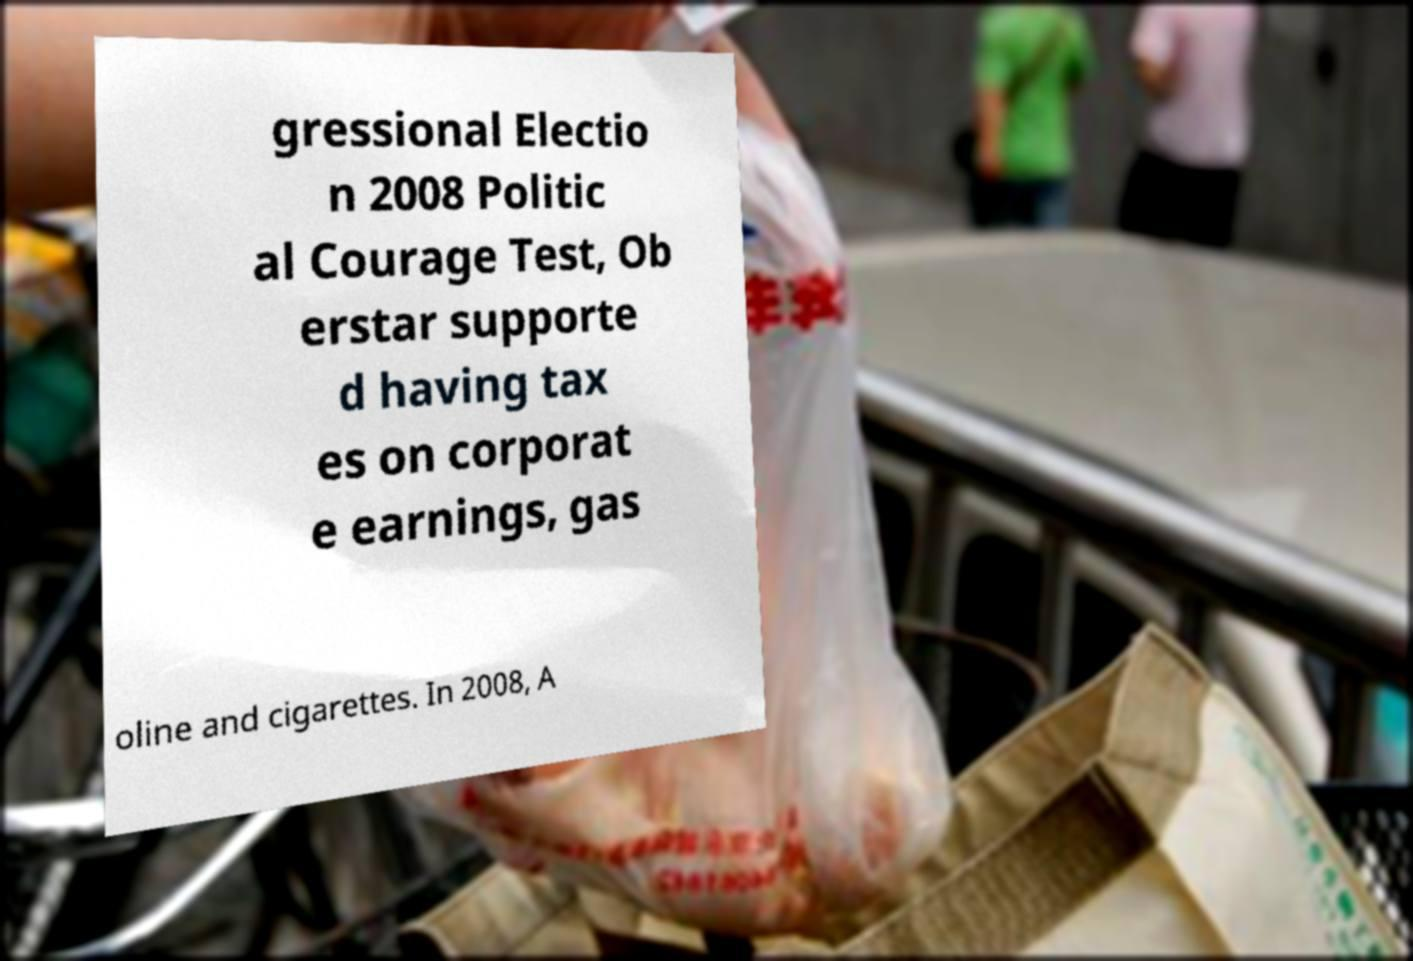Can you accurately transcribe the text from the provided image for me? gressional Electio n 2008 Politic al Courage Test, Ob erstar supporte d having tax es on corporat e earnings, gas oline and cigarettes. In 2008, A 